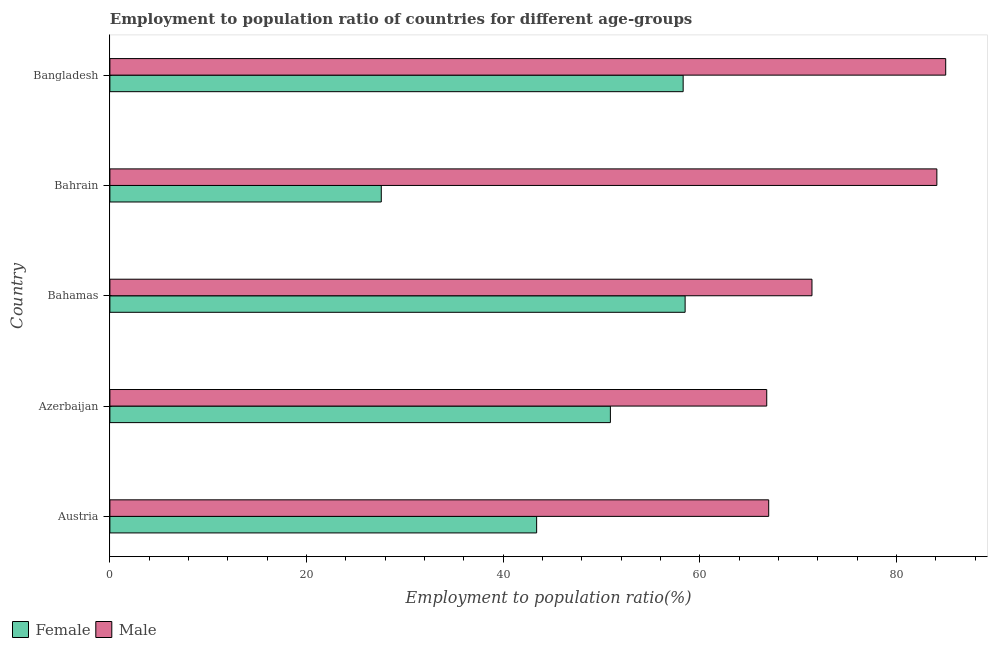How many groups of bars are there?
Your answer should be very brief. 5. Are the number of bars per tick equal to the number of legend labels?
Your answer should be very brief. Yes. Are the number of bars on each tick of the Y-axis equal?
Your response must be concise. Yes. How many bars are there on the 5th tick from the bottom?
Provide a short and direct response. 2. What is the label of the 3rd group of bars from the top?
Offer a very short reply. Bahamas. In how many cases, is the number of bars for a given country not equal to the number of legend labels?
Make the answer very short. 0. What is the employment to population ratio(female) in Bangladesh?
Keep it short and to the point. 58.3. Across all countries, what is the minimum employment to population ratio(female)?
Offer a very short reply. 27.6. In which country was the employment to population ratio(female) maximum?
Keep it short and to the point. Bahamas. In which country was the employment to population ratio(female) minimum?
Your response must be concise. Bahrain. What is the total employment to population ratio(female) in the graph?
Your answer should be very brief. 238.7. What is the difference between the employment to population ratio(male) in Austria and that in Bangladesh?
Provide a short and direct response. -18. What is the difference between the employment to population ratio(male) in Austria and the employment to population ratio(female) in Azerbaijan?
Offer a very short reply. 16.1. What is the average employment to population ratio(male) per country?
Your answer should be compact. 74.86. What is the difference between the employment to population ratio(male) and employment to population ratio(female) in Azerbaijan?
Make the answer very short. 15.9. In how many countries, is the employment to population ratio(male) greater than 52 %?
Your answer should be compact. 5. What is the ratio of the employment to population ratio(male) in Azerbaijan to that in Bahamas?
Provide a succinct answer. 0.94. What is the difference between the highest and the lowest employment to population ratio(male)?
Provide a short and direct response. 18.2. Is the sum of the employment to population ratio(male) in Azerbaijan and Bangladesh greater than the maximum employment to population ratio(female) across all countries?
Provide a short and direct response. Yes. How many bars are there?
Offer a terse response. 10. Does the graph contain grids?
Your answer should be compact. No. Where does the legend appear in the graph?
Provide a succinct answer. Bottom left. How many legend labels are there?
Provide a succinct answer. 2. What is the title of the graph?
Offer a very short reply. Employment to population ratio of countries for different age-groups. What is the Employment to population ratio(%) in Female in Austria?
Your response must be concise. 43.4. What is the Employment to population ratio(%) of Female in Azerbaijan?
Give a very brief answer. 50.9. What is the Employment to population ratio(%) of Male in Azerbaijan?
Your answer should be compact. 66.8. What is the Employment to population ratio(%) in Female in Bahamas?
Offer a terse response. 58.5. What is the Employment to population ratio(%) of Male in Bahamas?
Your response must be concise. 71.4. What is the Employment to population ratio(%) of Female in Bahrain?
Your response must be concise. 27.6. What is the Employment to population ratio(%) of Male in Bahrain?
Your answer should be very brief. 84.1. What is the Employment to population ratio(%) in Female in Bangladesh?
Ensure brevity in your answer.  58.3. What is the Employment to population ratio(%) of Male in Bangladesh?
Your answer should be very brief. 85. Across all countries, what is the maximum Employment to population ratio(%) in Female?
Your answer should be very brief. 58.5. Across all countries, what is the minimum Employment to population ratio(%) in Female?
Your response must be concise. 27.6. Across all countries, what is the minimum Employment to population ratio(%) of Male?
Offer a terse response. 66.8. What is the total Employment to population ratio(%) in Female in the graph?
Provide a short and direct response. 238.7. What is the total Employment to population ratio(%) of Male in the graph?
Offer a very short reply. 374.3. What is the difference between the Employment to population ratio(%) of Female in Austria and that in Bahamas?
Provide a succinct answer. -15.1. What is the difference between the Employment to population ratio(%) in Male in Austria and that in Bahrain?
Give a very brief answer. -17.1. What is the difference between the Employment to population ratio(%) in Female in Austria and that in Bangladesh?
Give a very brief answer. -14.9. What is the difference between the Employment to population ratio(%) of Female in Azerbaijan and that in Bahamas?
Ensure brevity in your answer.  -7.6. What is the difference between the Employment to population ratio(%) in Male in Azerbaijan and that in Bahamas?
Your answer should be very brief. -4.6. What is the difference between the Employment to population ratio(%) in Female in Azerbaijan and that in Bahrain?
Your answer should be compact. 23.3. What is the difference between the Employment to population ratio(%) of Male in Azerbaijan and that in Bahrain?
Your answer should be very brief. -17.3. What is the difference between the Employment to population ratio(%) in Female in Azerbaijan and that in Bangladesh?
Your answer should be very brief. -7.4. What is the difference between the Employment to population ratio(%) of Male in Azerbaijan and that in Bangladesh?
Offer a terse response. -18.2. What is the difference between the Employment to population ratio(%) in Female in Bahamas and that in Bahrain?
Provide a short and direct response. 30.9. What is the difference between the Employment to population ratio(%) in Male in Bahamas and that in Bahrain?
Your answer should be very brief. -12.7. What is the difference between the Employment to population ratio(%) of Male in Bahamas and that in Bangladesh?
Offer a terse response. -13.6. What is the difference between the Employment to population ratio(%) in Female in Bahrain and that in Bangladesh?
Your answer should be very brief. -30.7. What is the difference between the Employment to population ratio(%) in Female in Austria and the Employment to population ratio(%) in Male in Azerbaijan?
Offer a very short reply. -23.4. What is the difference between the Employment to population ratio(%) of Female in Austria and the Employment to population ratio(%) of Male in Bahrain?
Provide a succinct answer. -40.7. What is the difference between the Employment to population ratio(%) in Female in Austria and the Employment to population ratio(%) in Male in Bangladesh?
Provide a succinct answer. -41.6. What is the difference between the Employment to population ratio(%) of Female in Azerbaijan and the Employment to population ratio(%) of Male in Bahamas?
Your answer should be very brief. -20.5. What is the difference between the Employment to population ratio(%) in Female in Azerbaijan and the Employment to population ratio(%) in Male in Bahrain?
Provide a short and direct response. -33.2. What is the difference between the Employment to population ratio(%) in Female in Azerbaijan and the Employment to population ratio(%) in Male in Bangladesh?
Provide a short and direct response. -34.1. What is the difference between the Employment to population ratio(%) in Female in Bahamas and the Employment to population ratio(%) in Male in Bahrain?
Provide a short and direct response. -25.6. What is the difference between the Employment to population ratio(%) in Female in Bahamas and the Employment to population ratio(%) in Male in Bangladesh?
Provide a short and direct response. -26.5. What is the difference between the Employment to population ratio(%) of Female in Bahrain and the Employment to population ratio(%) of Male in Bangladesh?
Your response must be concise. -57.4. What is the average Employment to population ratio(%) of Female per country?
Your response must be concise. 47.74. What is the average Employment to population ratio(%) in Male per country?
Your response must be concise. 74.86. What is the difference between the Employment to population ratio(%) in Female and Employment to population ratio(%) in Male in Austria?
Your answer should be compact. -23.6. What is the difference between the Employment to population ratio(%) in Female and Employment to population ratio(%) in Male in Azerbaijan?
Your answer should be compact. -15.9. What is the difference between the Employment to population ratio(%) of Female and Employment to population ratio(%) of Male in Bahrain?
Ensure brevity in your answer.  -56.5. What is the difference between the Employment to population ratio(%) of Female and Employment to population ratio(%) of Male in Bangladesh?
Offer a terse response. -26.7. What is the ratio of the Employment to population ratio(%) in Female in Austria to that in Azerbaijan?
Make the answer very short. 0.85. What is the ratio of the Employment to population ratio(%) of Female in Austria to that in Bahamas?
Provide a short and direct response. 0.74. What is the ratio of the Employment to population ratio(%) in Male in Austria to that in Bahamas?
Your answer should be very brief. 0.94. What is the ratio of the Employment to population ratio(%) of Female in Austria to that in Bahrain?
Provide a succinct answer. 1.57. What is the ratio of the Employment to population ratio(%) in Male in Austria to that in Bahrain?
Ensure brevity in your answer.  0.8. What is the ratio of the Employment to population ratio(%) in Female in Austria to that in Bangladesh?
Your response must be concise. 0.74. What is the ratio of the Employment to population ratio(%) in Male in Austria to that in Bangladesh?
Your response must be concise. 0.79. What is the ratio of the Employment to population ratio(%) in Female in Azerbaijan to that in Bahamas?
Your answer should be very brief. 0.87. What is the ratio of the Employment to population ratio(%) in Male in Azerbaijan to that in Bahamas?
Your answer should be very brief. 0.94. What is the ratio of the Employment to population ratio(%) in Female in Azerbaijan to that in Bahrain?
Your answer should be very brief. 1.84. What is the ratio of the Employment to population ratio(%) in Male in Azerbaijan to that in Bahrain?
Your response must be concise. 0.79. What is the ratio of the Employment to population ratio(%) in Female in Azerbaijan to that in Bangladesh?
Provide a short and direct response. 0.87. What is the ratio of the Employment to population ratio(%) of Male in Azerbaijan to that in Bangladesh?
Make the answer very short. 0.79. What is the ratio of the Employment to population ratio(%) in Female in Bahamas to that in Bahrain?
Keep it short and to the point. 2.12. What is the ratio of the Employment to population ratio(%) in Male in Bahamas to that in Bahrain?
Provide a short and direct response. 0.85. What is the ratio of the Employment to population ratio(%) of Male in Bahamas to that in Bangladesh?
Your answer should be compact. 0.84. What is the ratio of the Employment to population ratio(%) of Female in Bahrain to that in Bangladesh?
Your answer should be compact. 0.47. What is the difference between the highest and the second highest Employment to population ratio(%) of Male?
Provide a short and direct response. 0.9. What is the difference between the highest and the lowest Employment to population ratio(%) of Female?
Make the answer very short. 30.9. What is the difference between the highest and the lowest Employment to population ratio(%) in Male?
Give a very brief answer. 18.2. 